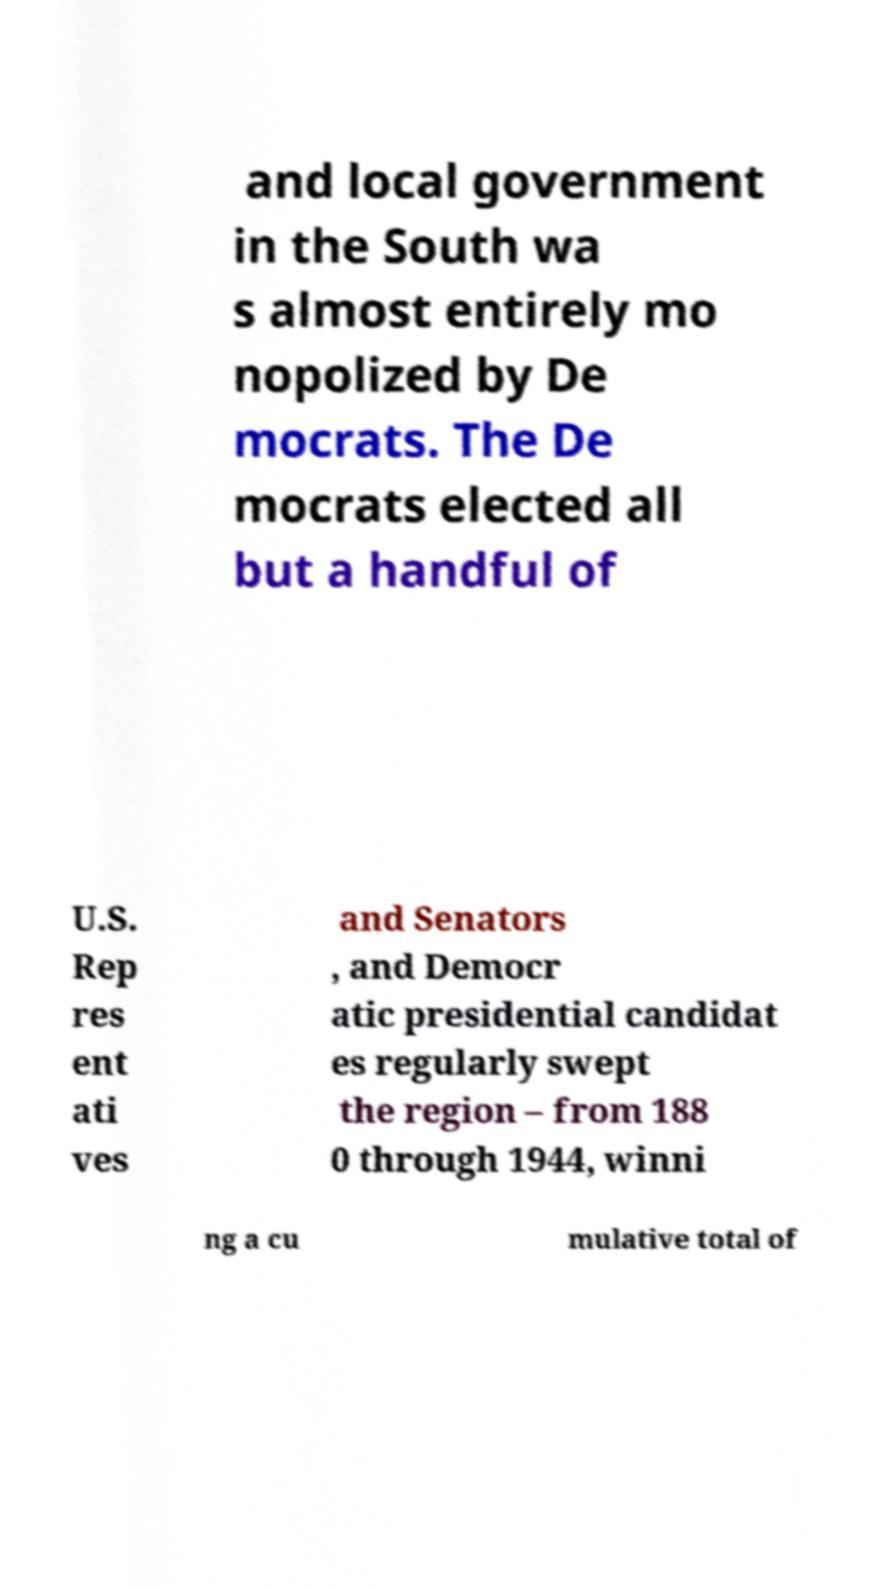Please identify and transcribe the text found in this image. and local government in the South wa s almost entirely mo nopolized by De mocrats. The De mocrats elected all but a handful of U.S. Rep res ent ati ves and Senators , and Democr atic presidential candidat es regularly swept the region – from 188 0 through 1944, winni ng a cu mulative total of 